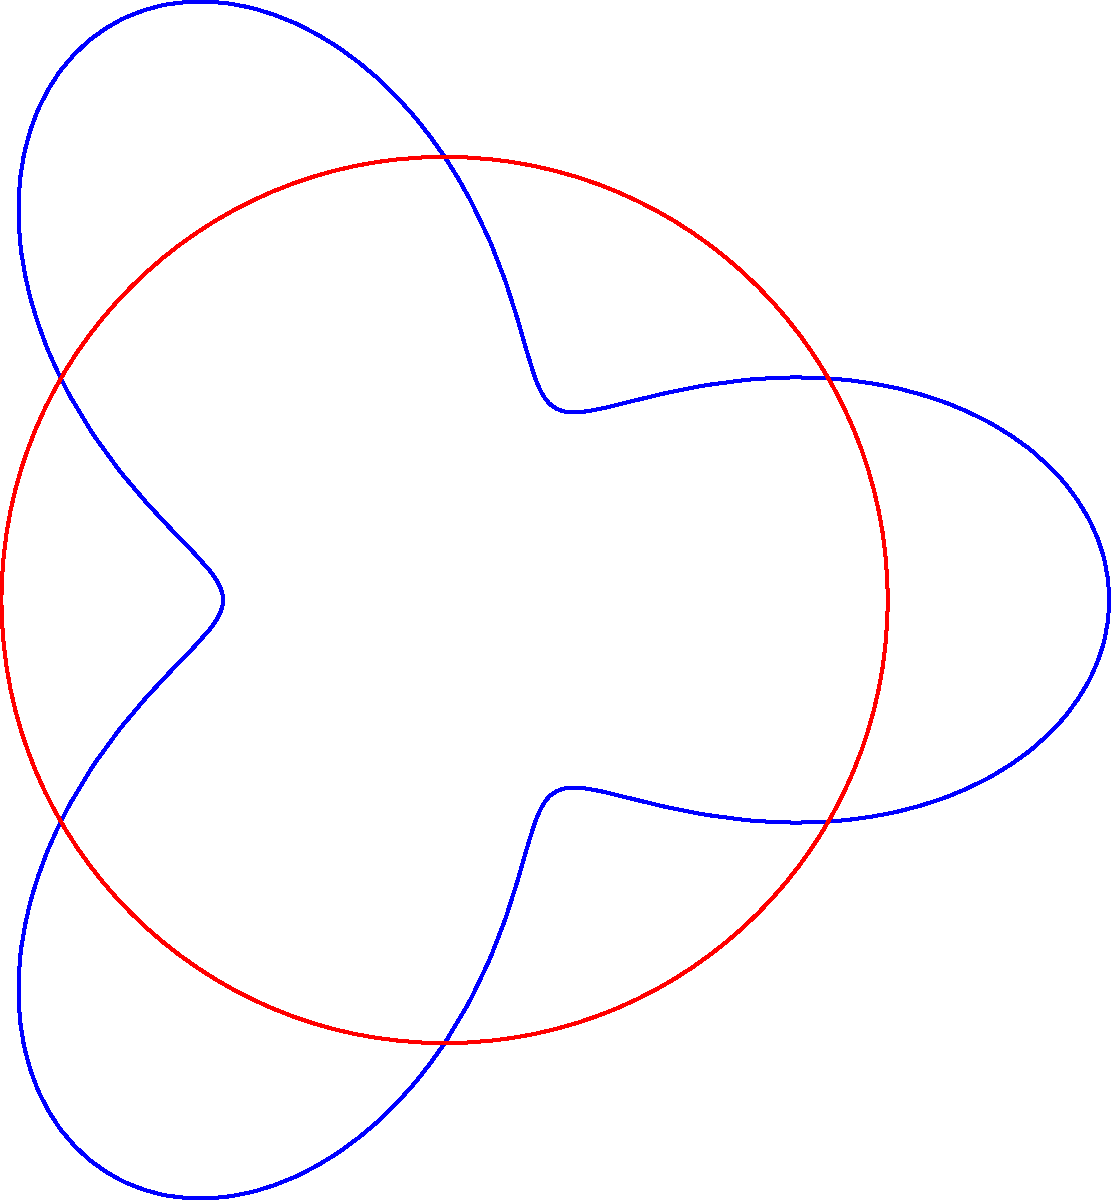In the polar coordinate system shown, a football player's running route is represented by the blue curve $r = 2 + \cos(3\theta)$, while a robot's programmed circular path is shown in red. If the player completes one full rotation, how many times does their path intersect with the robot's path? To solve this problem, we need to follow these steps:

1) The player's path is given by $r = 2 + \cos(3\theta)$, which is a rose curve with 3 petals.

2) The robot's path is a circle with radius 2, given by $r = 2$.

3) To find the intersections, we need to solve the equation:
   $2 + \cos(3\theta) = 2$

4) This simplifies to:
   $\cos(3\theta) = 0$

5) The solutions to this equation are:
   $3\theta = \frac{\pi}{2}, \frac{3\pi}{2}, \frac{5\pi}{2}$

6) Solving for $\theta$:
   $\theta = \frac{\pi}{6}, \frac{\pi}{2}, \frac{5\pi}{6}$

7) These are the angles where the paths intersect in the first quadrant. Due to the symmetry of the rose curve, these intersections will repeat in each quadrant.

8) Since there are 4 quadrants, and 3 intersections per quadrant, the total number of intersections is $4 * 3 = 12$.

Therefore, the player's path intersects with the robot's path 12 times in one full rotation.
Answer: 12 times 